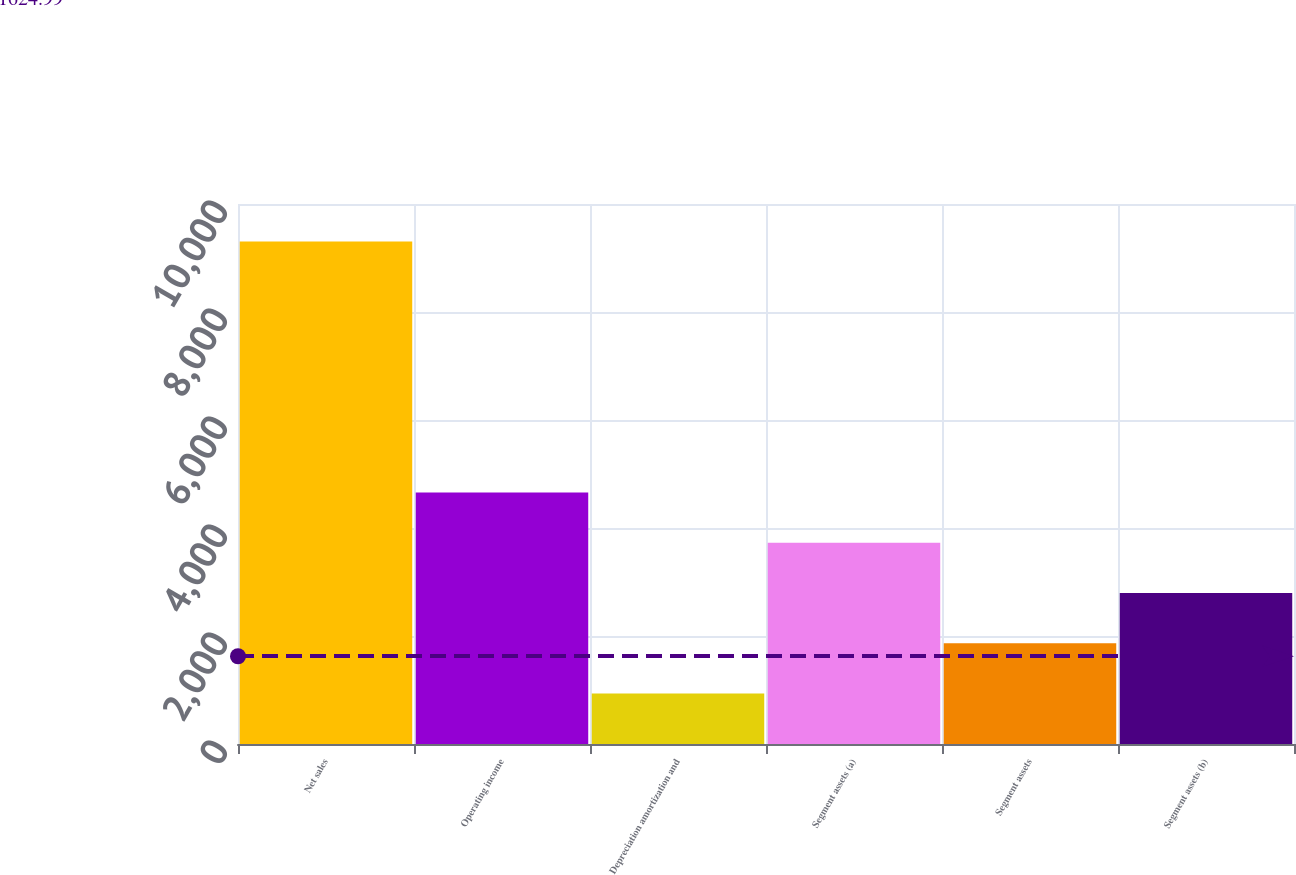<chart> <loc_0><loc_0><loc_500><loc_500><bar_chart><fcel>Net sales<fcel>Operating income<fcel>Depreciation amortization and<fcel>Segment assets (a)<fcel>Segment assets<fcel>Segment assets (b)<nl><fcel>9307<fcel>4656.5<fcel>936.1<fcel>3726.4<fcel>1866.2<fcel>2796.3<nl></chart> 